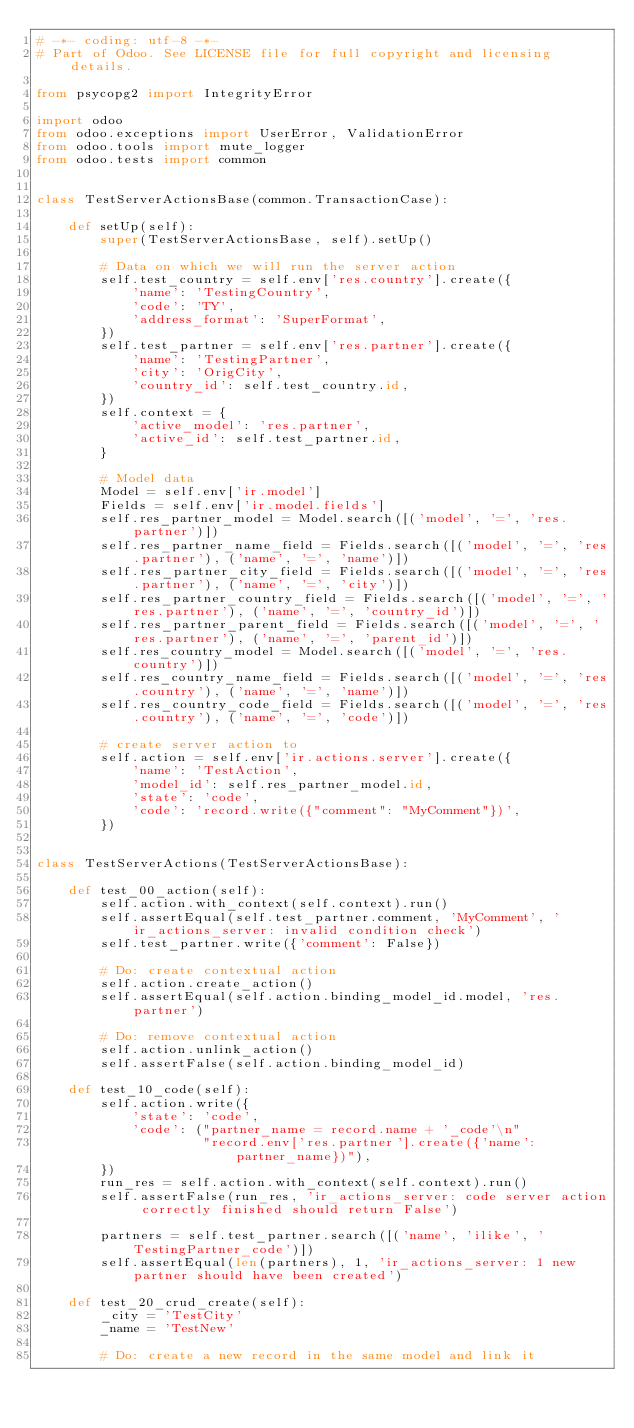Convert code to text. <code><loc_0><loc_0><loc_500><loc_500><_Python_># -*- coding: utf-8 -*-
# Part of Odoo. See LICENSE file for full copyright and licensing details.

from psycopg2 import IntegrityError

import odoo
from odoo.exceptions import UserError, ValidationError
from odoo.tools import mute_logger
from odoo.tests import common


class TestServerActionsBase(common.TransactionCase):

    def setUp(self):
        super(TestServerActionsBase, self).setUp()

        # Data on which we will run the server action
        self.test_country = self.env['res.country'].create({
            'name': 'TestingCountry',
            'code': 'TY',
            'address_format': 'SuperFormat',
        })
        self.test_partner = self.env['res.partner'].create({
            'name': 'TestingPartner',
            'city': 'OrigCity',
            'country_id': self.test_country.id,
        })
        self.context = {
            'active_model': 'res.partner',
            'active_id': self.test_partner.id,
        }

        # Model data
        Model = self.env['ir.model']
        Fields = self.env['ir.model.fields']
        self.res_partner_model = Model.search([('model', '=', 'res.partner')])
        self.res_partner_name_field = Fields.search([('model', '=', 'res.partner'), ('name', '=', 'name')])
        self.res_partner_city_field = Fields.search([('model', '=', 'res.partner'), ('name', '=', 'city')])
        self.res_partner_country_field = Fields.search([('model', '=', 'res.partner'), ('name', '=', 'country_id')])
        self.res_partner_parent_field = Fields.search([('model', '=', 'res.partner'), ('name', '=', 'parent_id')])
        self.res_country_model = Model.search([('model', '=', 'res.country')])
        self.res_country_name_field = Fields.search([('model', '=', 'res.country'), ('name', '=', 'name')])
        self.res_country_code_field = Fields.search([('model', '=', 'res.country'), ('name', '=', 'code')])

        # create server action to
        self.action = self.env['ir.actions.server'].create({
            'name': 'TestAction',
            'model_id': self.res_partner_model.id,
            'state': 'code',
            'code': 'record.write({"comment": "MyComment"})',
        })


class TestServerActions(TestServerActionsBase):

    def test_00_action(self):
        self.action.with_context(self.context).run()
        self.assertEqual(self.test_partner.comment, 'MyComment', 'ir_actions_server: invalid condition check')
        self.test_partner.write({'comment': False})

        # Do: create contextual action
        self.action.create_action()
        self.assertEqual(self.action.binding_model_id.model, 'res.partner')

        # Do: remove contextual action
        self.action.unlink_action()
        self.assertFalse(self.action.binding_model_id)

    def test_10_code(self):
        self.action.write({
            'state': 'code',
            'code': ("partner_name = record.name + '_code'\n"
                     "record.env['res.partner'].create({'name': partner_name})"),
        })
        run_res = self.action.with_context(self.context).run()
        self.assertFalse(run_res, 'ir_actions_server: code server action correctly finished should return False')

        partners = self.test_partner.search([('name', 'ilike', 'TestingPartner_code')])
        self.assertEqual(len(partners), 1, 'ir_actions_server: 1 new partner should have been created')

    def test_20_crud_create(self):
        _city = 'TestCity'
        _name = 'TestNew'

        # Do: create a new record in the same model and link it</code> 